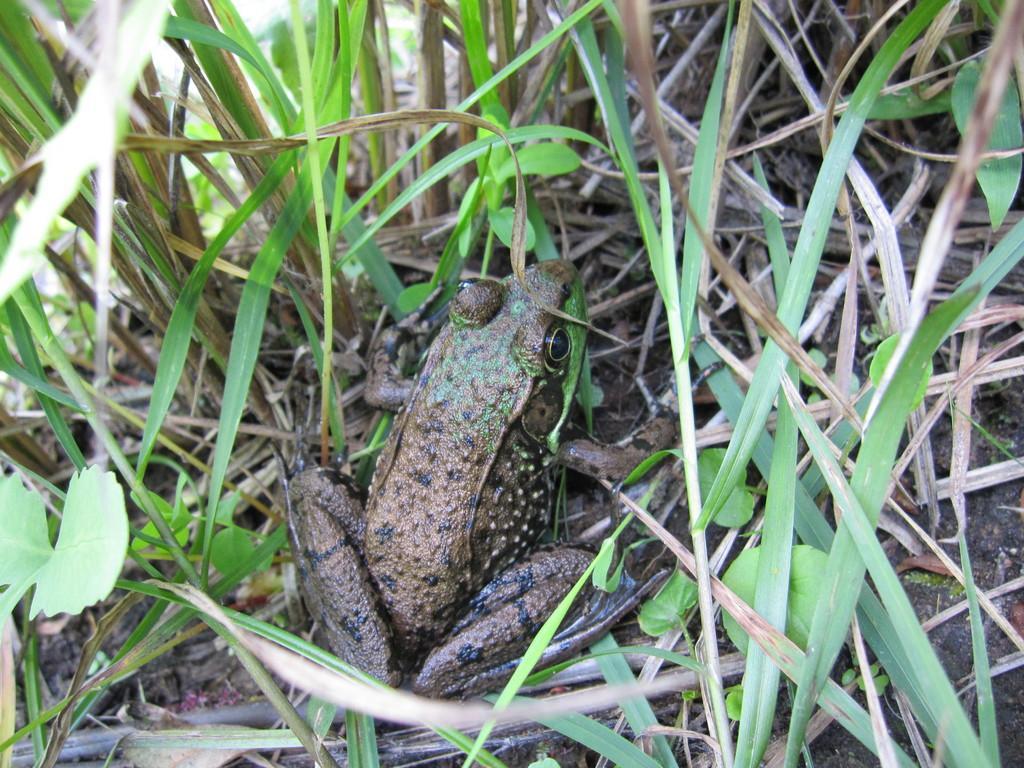In one or two sentences, can you explain what this image depicts? In the center of the picture there is a frog, and the frog there are plants, grass and soil. 